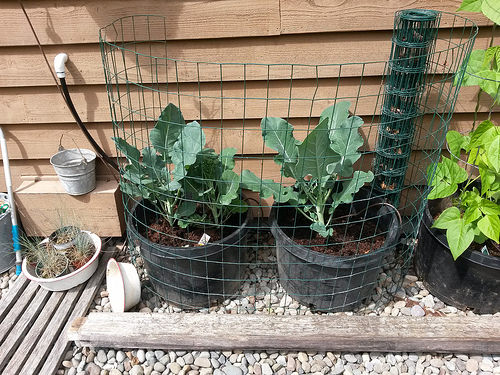<image>
Can you confirm if the plant is behind the cage? Yes. From this viewpoint, the plant is positioned behind the cage, with the cage partially or fully occluding the plant. 